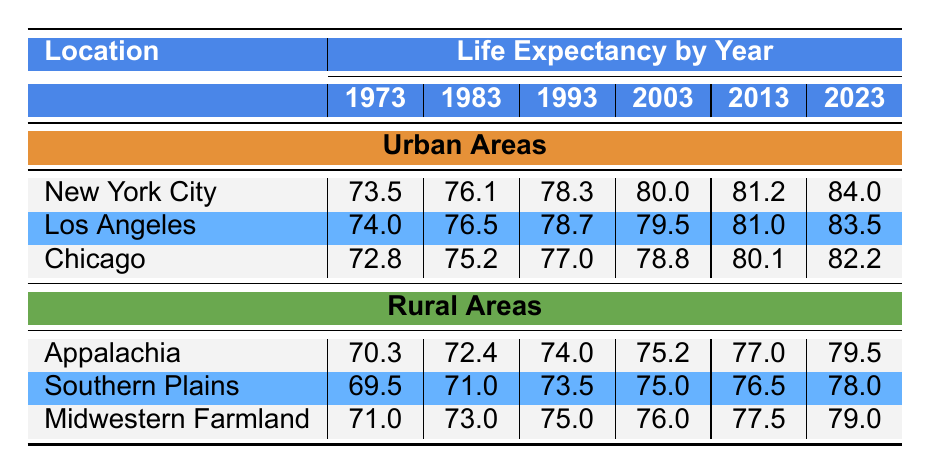What was the life expectancy in New York City in 1993? In the table, we look for the life expectancy value for New York City in the year 1993. The data shows that it was 78.3 years.
Answer: 78.3 What is the life expectancy in the Southern Plains region for the year 2023? The table reveals that in the year 2023, the life expectancy for the Southern Plains is 78.0 years.
Answer: 78.0 Which urban area had the lowest life expectancy in 1973? We compare the life expectancy values of New York City, Los Angeles, and Chicago for the year 1973. The values are 73.5, 74.0, and 72.8 respectively, showing that Chicago had the lowest at 72.8 years.
Answer: Chicago What is the average life expectancy of urban areas in 2013? To find the average for urban areas in 2013, we sum the life expectancies: New York City (81.2), Los Angeles (81.0), and Chicago (80.1) which totals 242.3. Dividing by 3 gives an average of 80.77.
Answer: 80.77 Is the life expectancy in Appalachia higher than that in Southern Plains in the year 2023? In the year 2023, the life expectancy in Appalachia is 79.5 years, while in Southern Plains it is 78.0 years. Since 79.5 is greater than 78.0, the statement is true.
Answer: Yes Which urban area shows the highest increase in life expectancy from 1973 to 2023? We calculate the increase for each urban area: New York City (84.0 - 73.5 = 10.5), Los Angeles (83.5 - 74.0 = 9.5), Chicago (82.2 - 72.8 = 9.4). New York City has the highest increase at 10.5 years.
Answer: New York City What is the difference in life expectancy between urban and rural areas in 2003? In 2003, the average life expectancy for urban areas is calculated as (80.0 + 79.5 + 78.8)/3 = 79.47, and for rural areas, it is calculated as (75.2 + 75.0 + 76.0)/3 = 75.4. The difference is 79.47 - 75.4 = 4.07.
Answer: 4.07 Is it true that life expectancy for all urban areas increased over the years between 1973 and 2023? Reviewing each urban area: New York City (73.5 to 84.0), Los Angeles (74.0 to 83.5), Chicago (72.8 to 82.2) shows all increased. Hence, the statement is true.
Answer: Yes What is the life expectancy in Midwestern Farmland in 2013? The table states that the life expectancy in Midwestern Farmland for 2013 is 77.5 years.
Answer: 77.5 